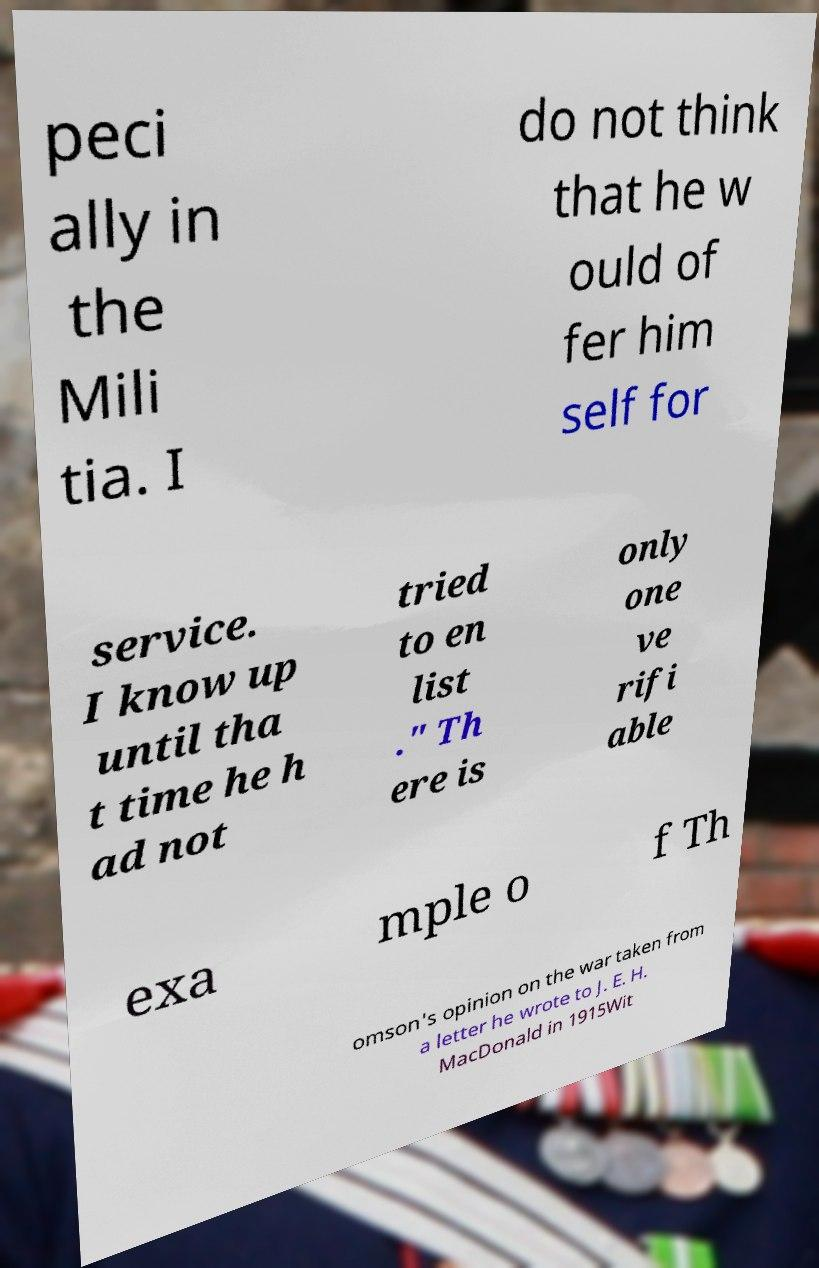Could you assist in decoding the text presented in this image and type it out clearly? peci ally in the Mili tia. I do not think that he w ould of fer him self for service. I know up until tha t time he h ad not tried to en list ." Th ere is only one ve rifi able exa mple o f Th omson's opinion on the war taken from a letter he wrote to J. E. H. MacDonald in 1915Wit 